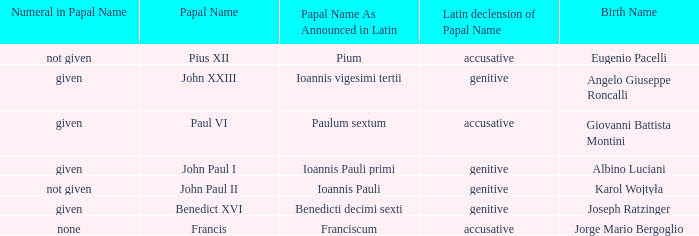For Pope Paul VI, what is the declension of his papal name? Accusative. 